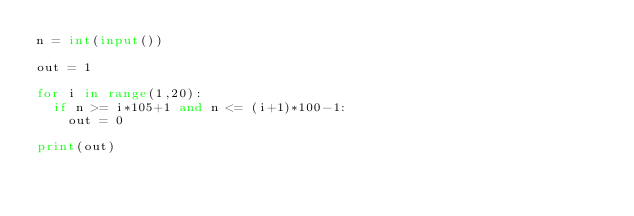<code> <loc_0><loc_0><loc_500><loc_500><_Python_>n = int(input())

out = 1

for i in range(1,20):
  if n >= i*105+1 and n <= (i+1)*100-1:
    out = 0

print(out)</code> 